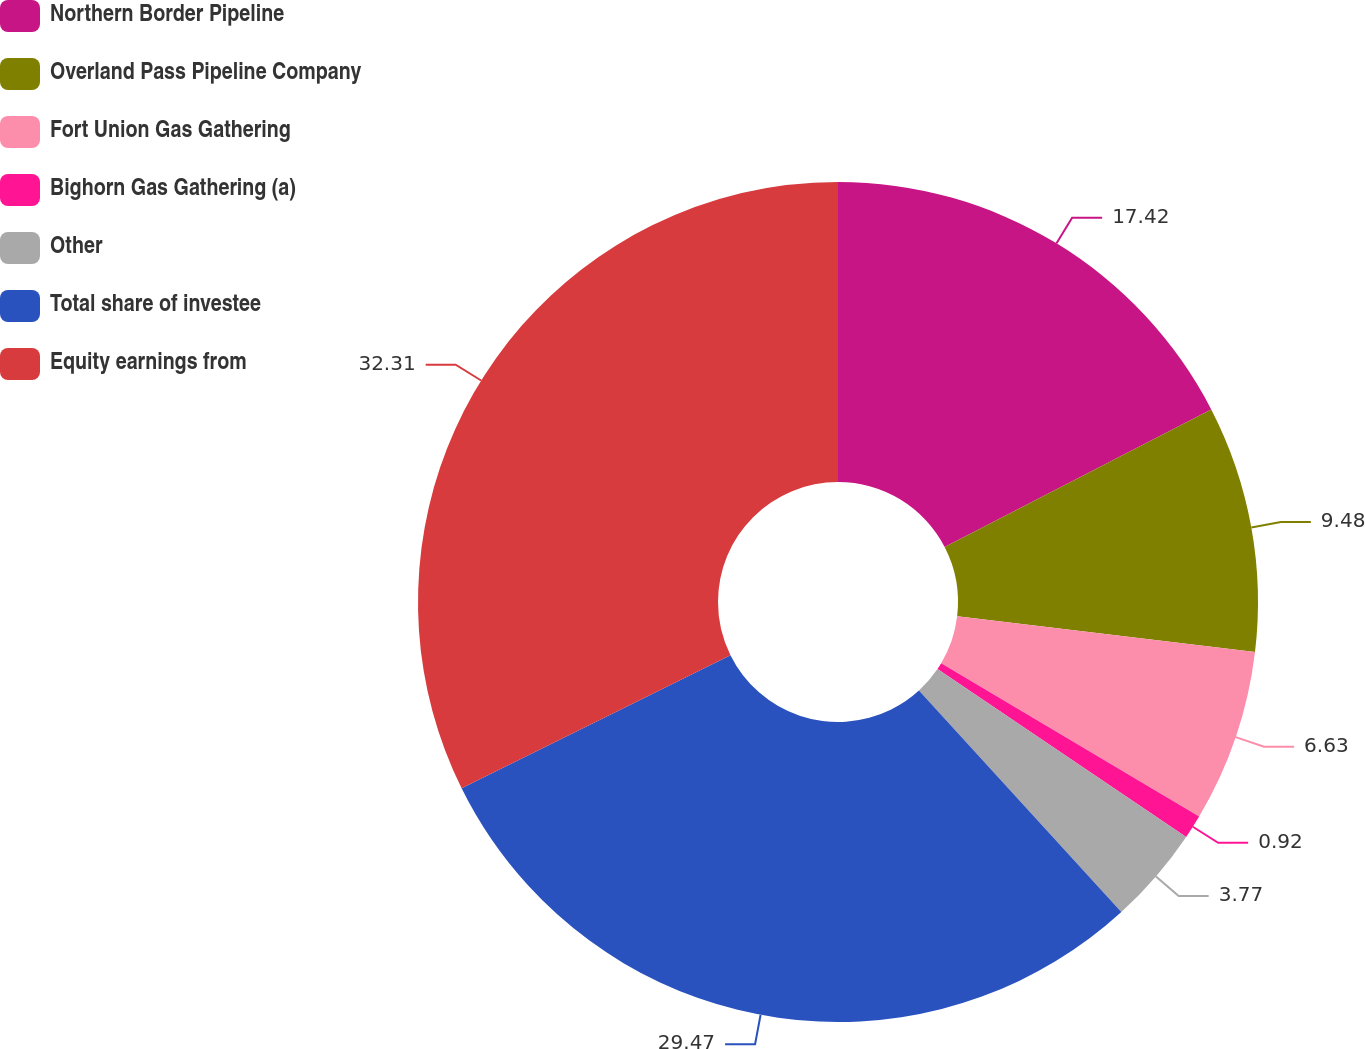Convert chart. <chart><loc_0><loc_0><loc_500><loc_500><pie_chart><fcel>Northern Border Pipeline<fcel>Overland Pass Pipeline Company<fcel>Fort Union Gas Gathering<fcel>Bighorn Gas Gathering (a)<fcel>Other<fcel>Total share of investee<fcel>Equity earnings from<nl><fcel>17.42%<fcel>9.48%<fcel>6.63%<fcel>0.92%<fcel>3.77%<fcel>29.47%<fcel>32.32%<nl></chart> 